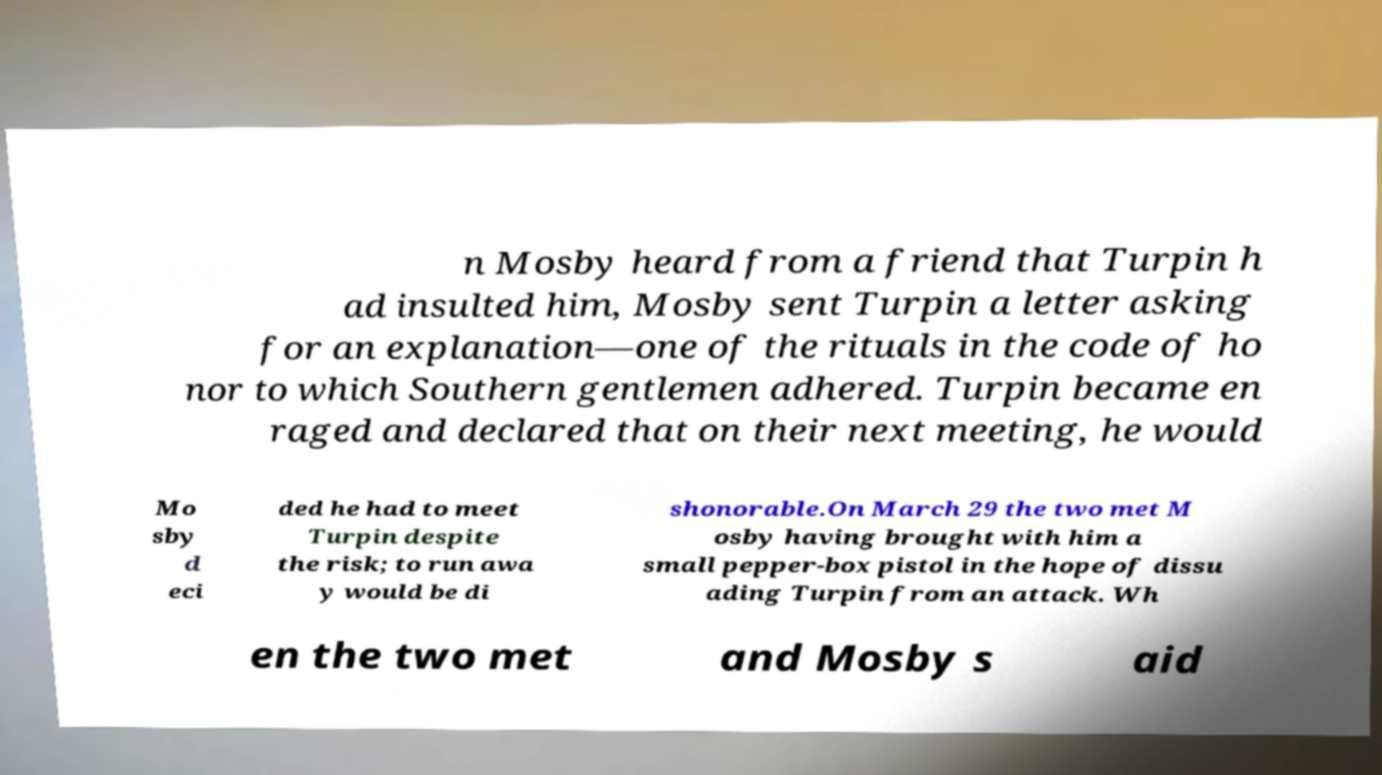What messages or text are displayed in this image? I need them in a readable, typed format. n Mosby heard from a friend that Turpin h ad insulted him, Mosby sent Turpin a letter asking for an explanation—one of the rituals in the code of ho nor to which Southern gentlemen adhered. Turpin became en raged and declared that on their next meeting, he would Mo sby d eci ded he had to meet Turpin despite the risk; to run awa y would be di shonorable.On March 29 the two met M osby having brought with him a small pepper-box pistol in the hope of dissu ading Turpin from an attack. Wh en the two met and Mosby s aid 